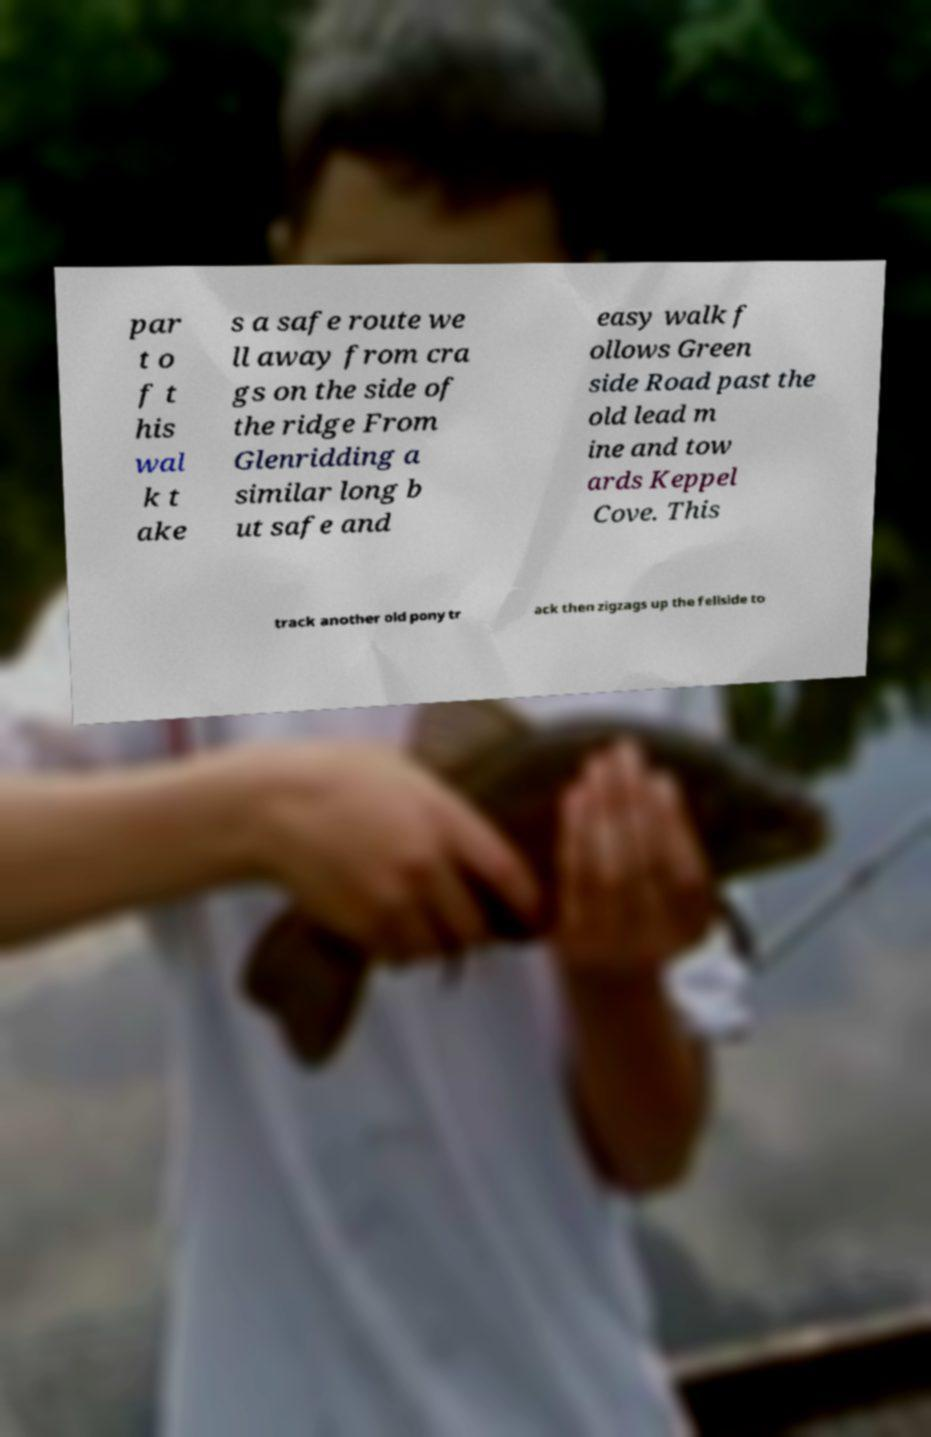Could you assist in decoding the text presented in this image and type it out clearly? par t o f t his wal k t ake s a safe route we ll away from cra gs on the side of the ridge From Glenridding a similar long b ut safe and easy walk f ollows Green side Road past the old lead m ine and tow ards Keppel Cove. This track another old pony tr ack then zigzags up the fellside to 